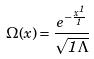<formula> <loc_0><loc_0><loc_500><loc_500>\Omega ( x ) = \frac { e ^ { - \frac { x ^ { 1 } } { 1 } } } { \sqrt { 1 \Lambda } }</formula> 